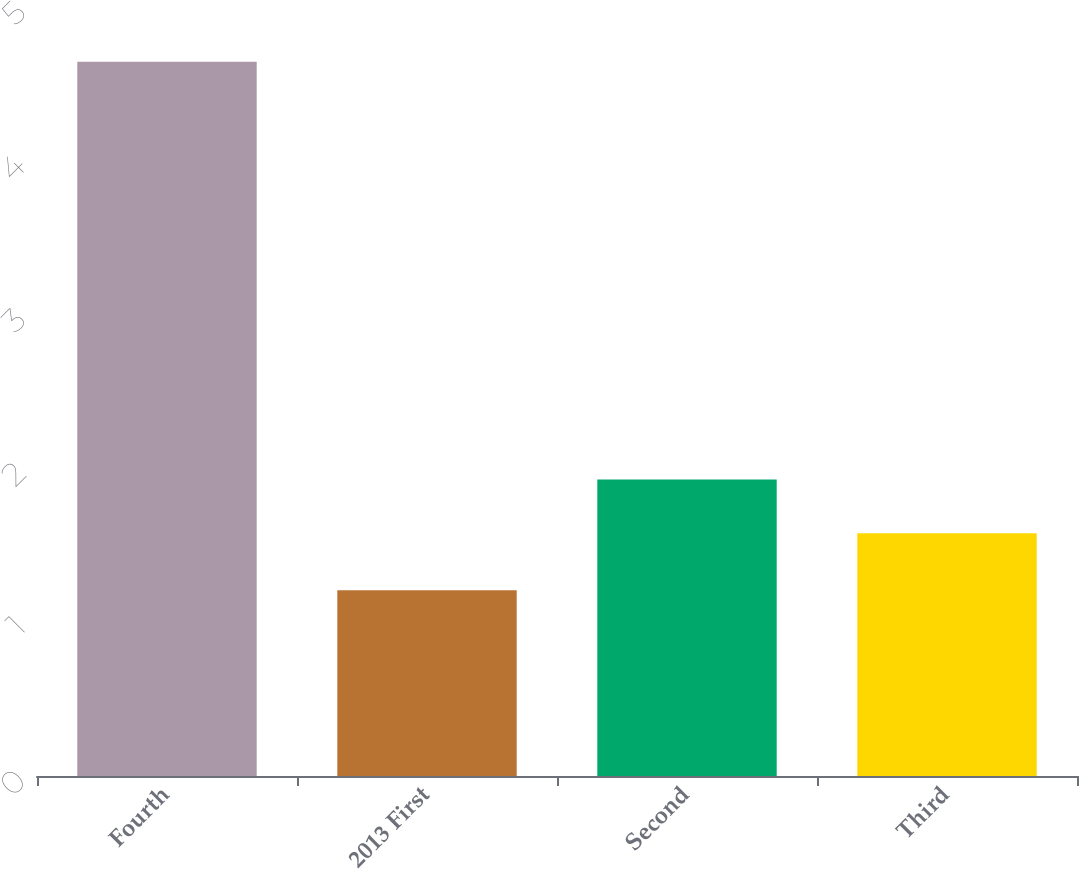<chart> <loc_0><loc_0><loc_500><loc_500><bar_chart><fcel>Fourth<fcel>2013 First<fcel>Second<fcel>Third<nl><fcel>4.65<fcel>1.21<fcel>1.93<fcel>1.58<nl></chart> 